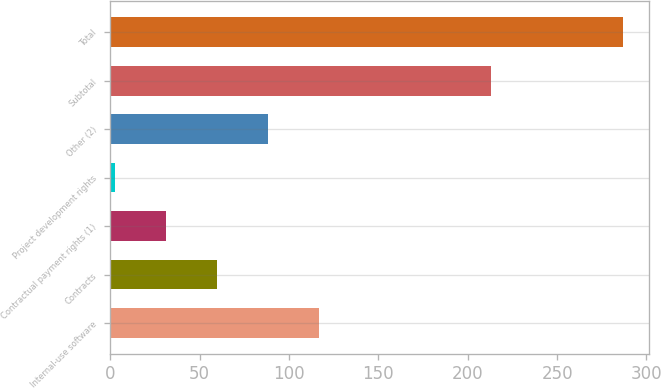<chart> <loc_0><loc_0><loc_500><loc_500><bar_chart><fcel>Internal-use software<fcel>Contracts<fcel>Contractual payment rights (1)<fcel>Project development rights<fcel>Other (2)<fcel>Subtotal<fcel>Total<nl><fcel>116.6<fcel>59.8<fcel>31.4<fcel>3<fcel>88.2<fcel>213<fcel>287<nl></chart> 